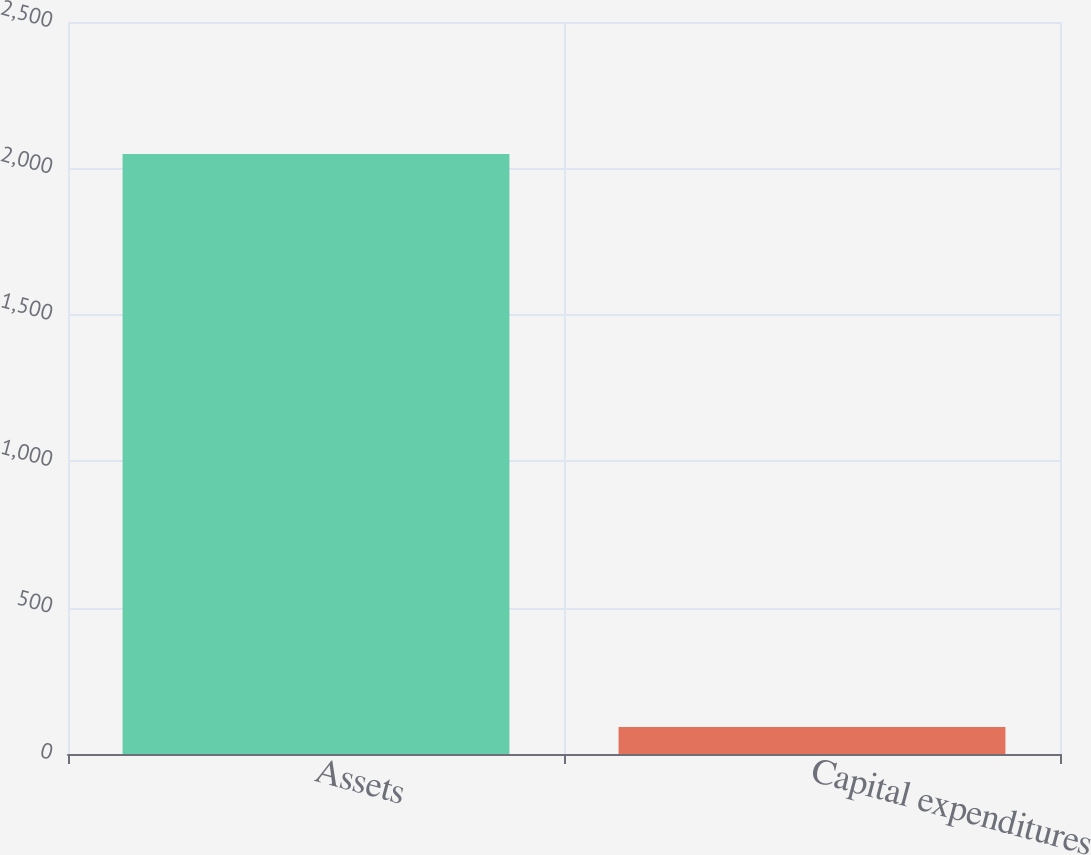<chart> <loc_0><loc_0><loc_500><loc_500><bar_chart><fcel>Assets<fcel>Capital expenditures<nl><fcel>2049<fcel>92<nl></chart> 